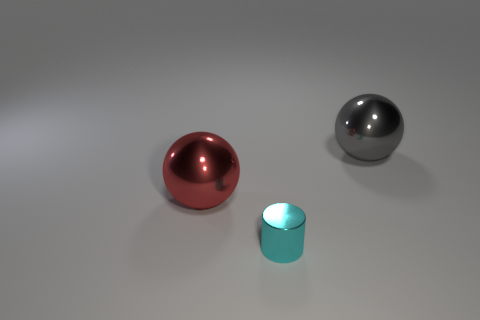There is a big red thing that is the same shape as the gray shiny thing; what material is it?
Your response must be concise. Metal. Are there more red things in front of the metal cylinder than large red metallic spheres?
Keep it short and to the point. No. How many big metal balls are behind the cyan metal thing?
Provide a succinct answer. 2. There is a tiny cyan thing that is to the left of the large metal object on the right side of the tiny cyan thing; is there a large metal object that is on the right side of it?
Your answer should be very brief. Yes. Do the cylinder and the red ball have the same size?
Your answer should be very brief. No. Are there an equal number of gray metal balls to the right of the big red ball and tiny cyan metallic objects left of the big gray thing?
Provide a short and direct response. Yes. The large metal object that is on the left side of the big gray ball has what shape?
Make the answer very short. Sphere. There is another metallic object that is the same size as the gray metal object; what is its shape?
Give a very brief answer. Sphere. There is a large thing in front of the large object that is behind the big thing that is to the left of the cyan metallic cylinder; what color is it?
Your answer should be compact. Red. Do the gray metal thing and the big red object have the same shape?
Offer a terse response. Yes. 